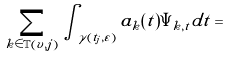Convert formula to latex. <formula><loc_0><loc_0><loc_500><loc_500>\sum _ { k \in \mathbb { T } ( v , j ) } \int \nolimits _ { \gamma ( t _ { j } , \varepsilon ) } a _ { k } ( t ) \Psi _ { k , t } d t =</formula> 